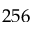<formula> <loc_0><loc_0><loc_500><loc_500>2 5 6</formula> 